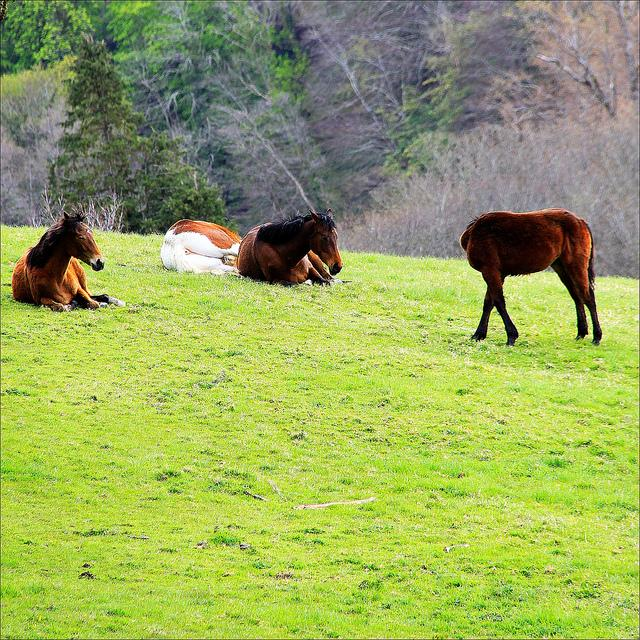Which of these horses would stand out in a dark setting? Please explain your reasoning. second left. The second left horse is white. 